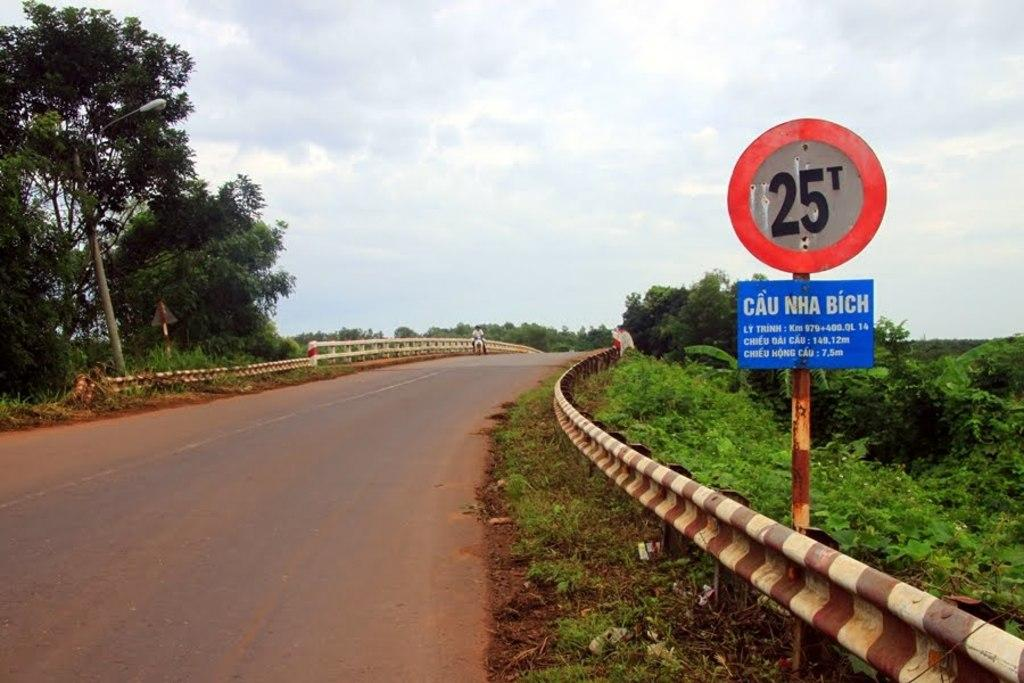<image>
Offer a succinct explanation of the picture presented. A sign that says 25T Cau Nha Bich on it. 